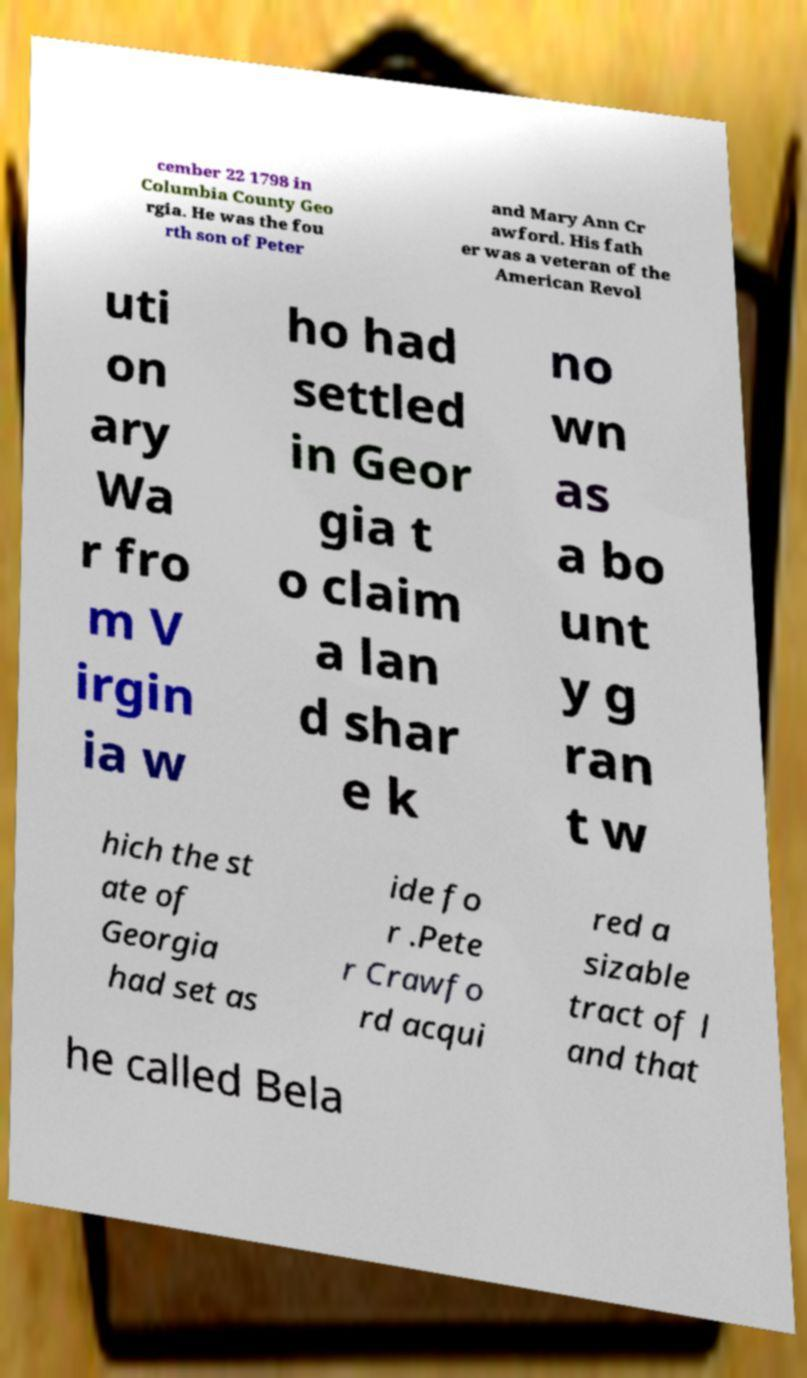Please identify and transcribe the text found in this image. cember 22 1798 in Columbia County Geo rgia. He was the fou rth son of Peter and Mary Ann Cr awford. His fath er was a veteran of the American Revol uti on ary Wa r fro m V irgin ia w ho had settled in Geor gia t o claim a lan d shar e k no wn as a bo unt y g ran t w hich the st ate of Georgia had set as ide fo r .Pete r Crawfo rd acqui red a sizable tract of l and that he called Bela 